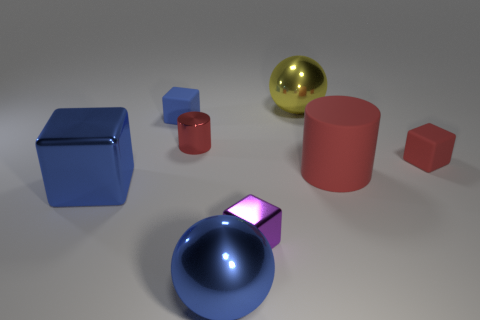There is a small rubber object that is left of the big matte cylinder; is it the same color as the big shiny cube?
Offer a very short reply. Yes. What material is the small red thing that is the same shape as the small blue rubber thing?
Your answer should be very brief. Rubber. The large object that is in front of the tiny metal object that is in front of the tiny rubber block that is on the right side of the yellow metallic sphere is what color?
Ensure brevity in your answer.  Blue. Are there fewer small cylinders than objects?
Your answer should be compact. Yes. What color is the tiny metallic object that is the same shape as the big red object?
Provide a short and direct response. Red. What is the color of the tiny block that is the same material as the large cube?
Keep it short and to the point. Purple. How many other matte cylinders are the same size as the red matte cylinder?
Provide a short and direct response. 0. What is the large cylinder made of?
Offer a terse response. Rubber. Is the number of big blue blocks greater than the number of small green cylinders?
Your answer should be compact. Yes. Does the tiny red rubber thing have the same shape as the small blue rubber object?
Give a very brief answer. Yes. 